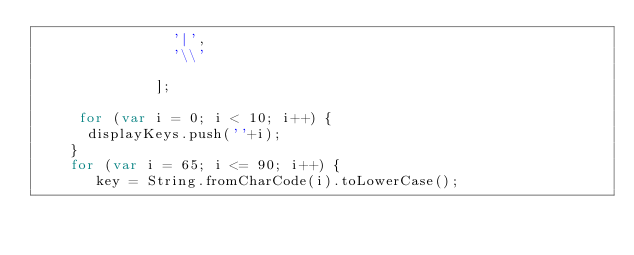<code> <loc_0><loc_0><loc_500><loc_500><_JavaScript_>                '|', 
                '\\'
                
              ];

     for (var i = 0; i < 10; i++) {
      displayKeys.push(''+i);
    }
    for (var i = 65; i <= 90; i++) {
       key = String.fromCharCode(i).toLowerCase();</code> 